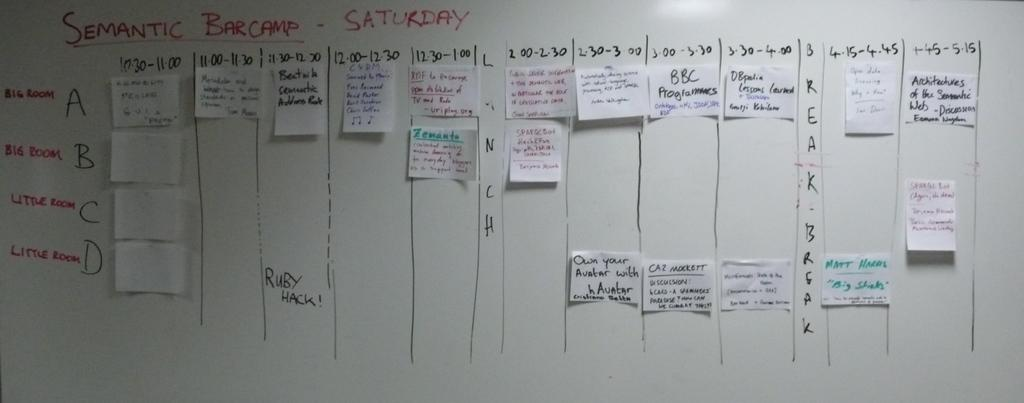<image>
Summarize the visual content of the image. The semantic bar camp information on the board is divided into vertical column.s 